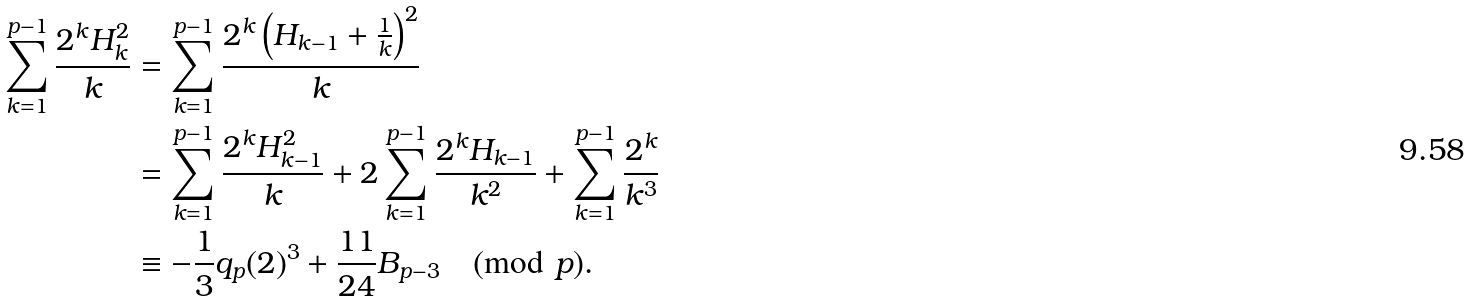<formula> <loc_0><loc_0><loc_500><loc_500>\sum _ { k = 1 } ^ { p - 1 } \frac { 2 ^ { k } H _ { k } ^ { 2 } } { k } & = \sum _ { k = 1 } ^ { p - 1 } \frac { 2 ^ { k } \left ( H _ { k - 1 } + \frac { 1 } { k } \right ) ^ { 2 } } { k } \\ & = \sum _ { k = 1 } ^ { p - 1 } \frac { 2 ^ { k } H _ { k - 1 } ^ { 2 } } { k } + 2 \sum _ { k = 1 } ^ { p - 1 } \frac { 2 ^ { k } H _ { k - 1 } } { k ^ { 2 } } + \sum _ { k = 1 } ^ { p - 1 } \frac { 2 ^ { k } } { k ^ { 3 } } \\ & \equiv - \frac { 1 } { 3 } q _ { p } ( 2 ) ^ { 3 } + \frac { 1 1 } { 2 4 } B _ { p - 3 } \pmod { p } .</formula> 